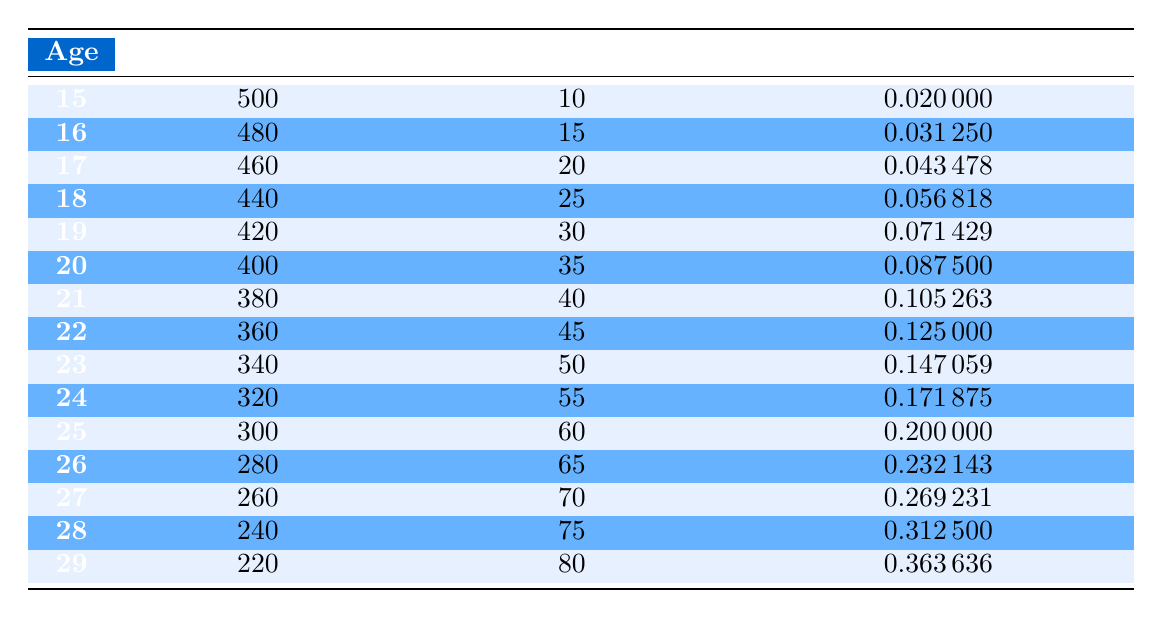What is the probability of competing nationally at age 18? From the table, the probability of competing nationally at age 18 is directly listed in the "Probability of Competing" column, which shows a value of 0.056818.
Answer: 0.056818 How many probable athletes are there at age 25? The number of probable athletes at age 25 is shown in the "Probable Athletes" column, which indicates 300.
Answer: 300 What is the total number of athletes competing nationally from age 15 to age 29? To find the total number of athletes competing nationally, we sum the values in the "Competing Nationally" column from age 15 (10) to age 29 (80): 10 + 15 + 20 + 25 + 30 + 35 + 40 + 45 + 50 + 55 + 60 + 65 + 70 + 75 + 80 = 485.
Answer: 485 Is the probability of competing nationally at age 29 greater than at age 22? The probability of competing nationally at age 29 is 0.363636, while at age 22 it is 0.125. Since 0.363636 is greater than 0.125, the statement is true.
Answer: Yes What is the average probability of competing nationally for athletes from age 20 to age 24? To find the average, we first sum the probabilities from age 20 (0.0875), age 21 (0.105263), age 22 (0.125), age 23 (0.147059), and age 24 (0.171875), which gives: 0.0875 + 0.105263 + 0.125 + 0.147059 + 0.171875 = 0.636697. We then divide by the number of ages (5) to get the average: 0.636697 / 5 = 0.1273394.
Answer: 0.1273394 At what age does the probability of competing nationally exceed 0.3 for the first time? By checking the "Probability of Competing" column, we see that the probability exceeds 0.3 at age 28 (0.3125), which is the first occurrence above this threshold, as the probabilities for ages 15 to 27 are all lower.
Answer: Age 28 